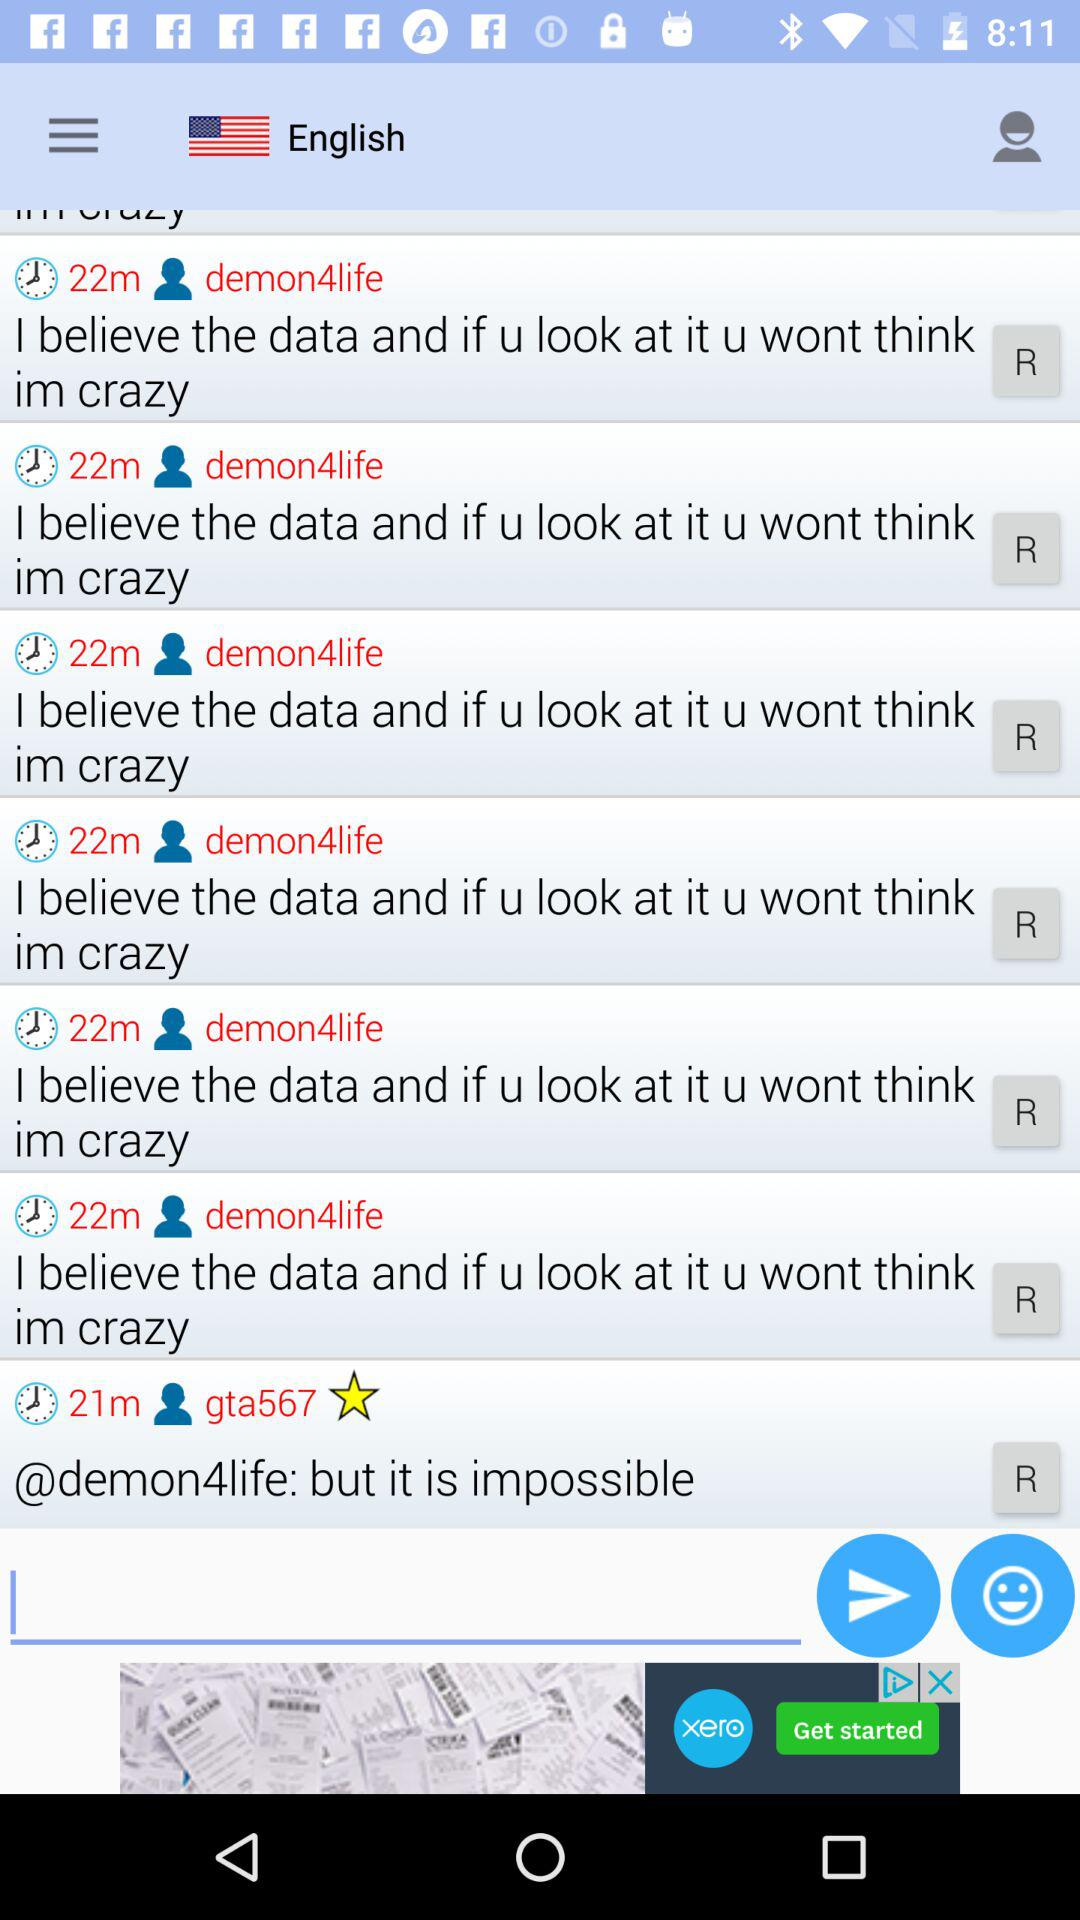What is the language? The language is English. 